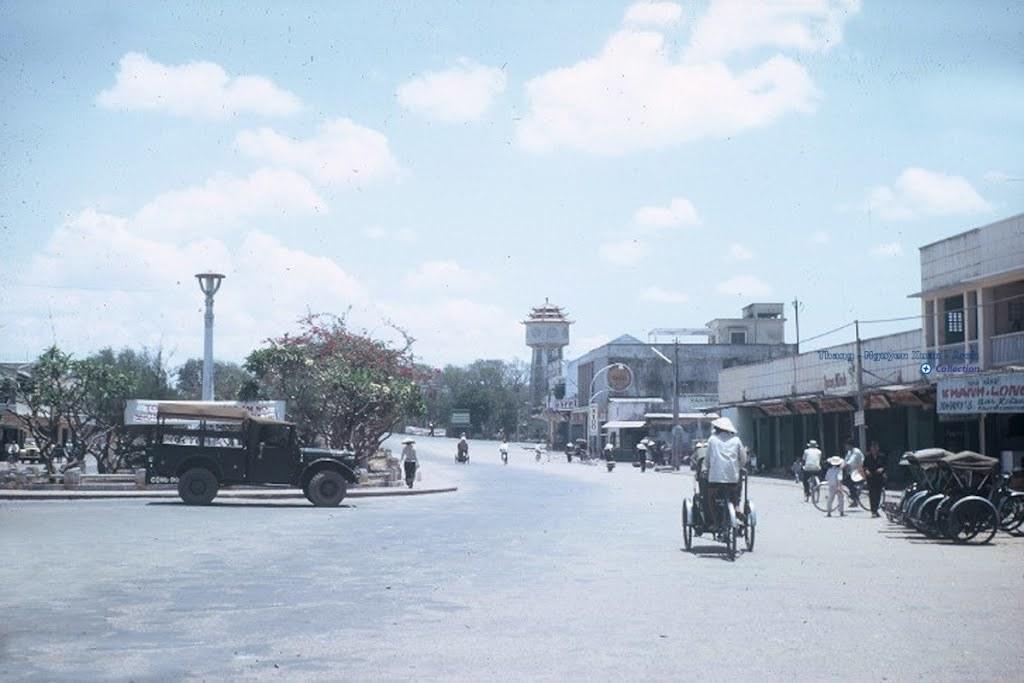Could you give a brief overview of what you see in this image? In this image there are a few vehicles moving on the road and few are Parked, there are a few people walking on the road and in the background of the image there are buildings, poles and the sky. 